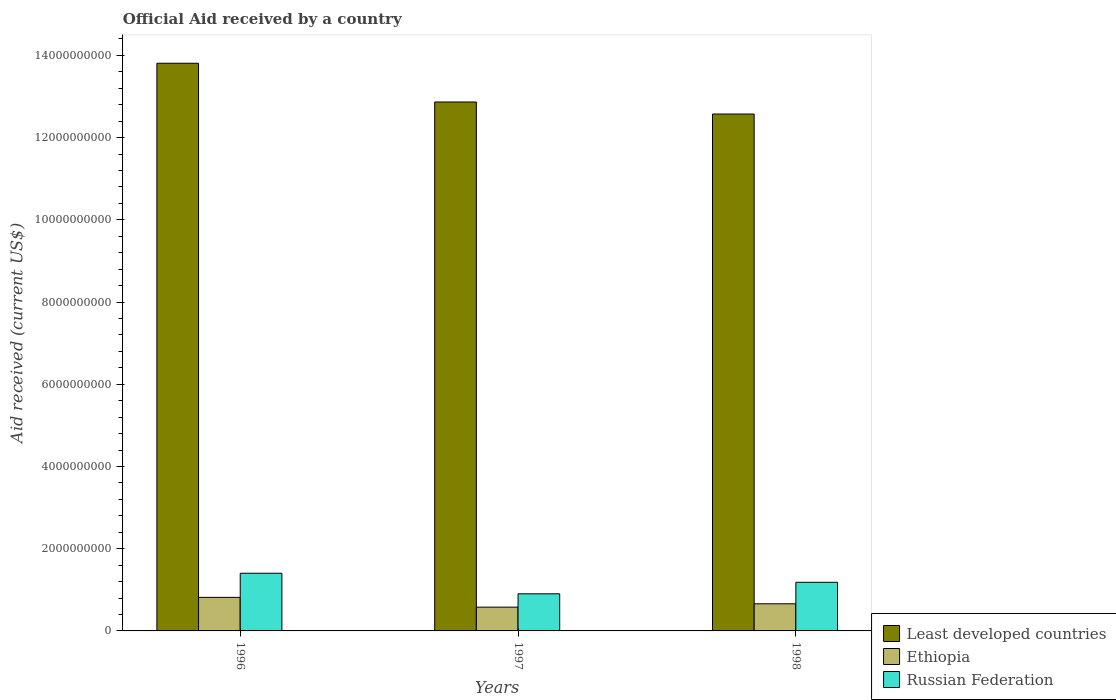How many different coloured bars are there?
Offer a terse response. 3. How many groups of bars are there?
Offer a terse response. 3. Are the number of bars per tick equal to the number of legend labels?
Offer a terse response. Yes. What is the label of the 1st group of bars from the left?
Your response must be concise. 1996. In how many cases, is the number of bars for a given year not equal to the number of legend labels?
Your answer should be compact. 0. What is the net official aid received in Ethiopia in 1997?
Your answer should be compact. 5.78e+08. Across all years, what is the maximum net official aid received in Ethiopia?
Give a very brief answer. 8.16e+08. Across all years, what is the minimum net official aid received in Ethiopia?
Provide a succinct answer. 5.78e+08. In which year was the net official aid received in Russian Federation maximum?
Ensure brevity in your answer.  1996. In which year was the net official aid received in Russian Federation minimum?
Provide a short and direct response. 1997. What is the total net official aid received in Ethiopia in the graph?
Ensure brevity in your answer.  2.05e+09. What is the difference between the net official aid received in Russian Federation in 1996 and that in 1997?
Your answer should be compact. 5.00e+08. What is the difference between the net official aid received in Ethiopia in 1998 and the net official aid received in Russian Federation in 1996?
Make the answer very short. -7.43e+08. What is the average net official aid received in Ethiopia per year?
Ensure brevity in your answer.  6.85e+08. In the year 1996, what is the difference between the net official aid received in Russian Federation and net official aid received in Ethiopia?
Offer a very short reply. 5.87e+08. What is the ratio of the net official aid received in Ethiopia in 1996 to that in 1998?
Ensure brevity in your answer.  1.24. Is the net official aid received in Russian Federation in 1997 less than that in 1998?
Provide a succinct answer. Yes. What is the difference between the highest and the second highest net official aid received in Least developed countries?
Keep it short and to the point. 9.42e+08. What is the difference between the highest and the lowest net official aid received in Ethiopia?
Make the answer very short. 2.38e+08. In how many years, is the net official aid received in Russian Federation greater than the average net official aid received in Russian Federation taken over all years?
Give a very brief answer. 2. Is the sum of the net official aid received in Least developed countries in 1997 and 1998 greater than the maximum net official aid received in Russian Federation across all years?
Make the answer very short. Yes. What does the 1st bar from the left in 1997 represents?
Offer a terse response. Least developed countries. What does the 3rd bar from the right in 1996 represents?
Keep it short and to the point. Least developed countries. Is it the case that in every year, the sum of the net official aid received in Least developed countries and net official aid received in Ethiopia is greater than the net official aid received in Russian Federation?
Keep it short and to the point. Yes. Are all the bars in the graph horizontal?
Provide a succinct answer. No. How many years are there in the graph?
Provide a succinct answer. 3. Where does the legend appear in the graph?
Make the answer very short. Bottom right. How many legend labels are there?
Keep it short and to the point. 3. How are the legend labels stacked?
Offer a very short reply. Vertical. What is the title of the graph?
Ensure brevity in your answer.  Official Aid received by a country. Does "Tajikistan" appear as one of the legend labels in the graph?
Keep it short and to the point. No. What is the label or title of the X-axis?
Give a very brief answer. Years. What is the label or title of the Y-axis?
Your answer should be very brief. Aid received (current US$). What is the Aid received (current US$) of Least developed countries in 1996?
Provide a short and direct response. 1.38e+1. What is the Aid received (current US$) in Ethiopia in 1996?
Keep it short and to the point. 8.16e+08. What is the Aid received (current US$) of Russian Federation in 1996?
Your answer should be compact. 1.40e+09. What is the Aid received (current US$) of Least developed countries in 1997?
Your response must be concise. 1.29e+1. What is the Aid received (current US$) in Ethiopia in 1997?
Ensure brevity in your answer.  5.78e+08. What is the Aid received (current US$) in Russian Federation in 1997?
Keep it short and to the point. 9.03e+08. What is the Aid received (current US$) of Least developed countries in 1998?
Keep it short and to the point. 1.26e+1. What is the Aid received (current US$) in Ethiopia in 1998?
Give a very brief answer. 6.60e+08. What is the Aid received (current US$) of Russian Federation in 1998?
Provide a succinct answer. 1.18e+09. Across all years, what is the maximum Aid received (current US$) of Least developed countries?
Keep it short and to the point. 1.38e+1. Across all years, what is the maximum Aid received (current US$) in Ethiopia?
Make the answer very short. 8.16e+08. Across all years, what is the maximum Aid received (current US$) in Russian Federation?
Your answer should be very brief. 1.40e+09. Across all years, what is the minimum Aid received (current US$) in Least developed countries?
Provide a succinct answer. 1.26e+1. Across all years, what is the minimum Aid received (current US$) in Ethiopia?
Ensure brevity in your answer.  5.78e+08. Across all years, what is the minimum Aid received (current US$) of Russian Federation?
Your response must be concise. 9.03e+08. What is the total Aid received (current US$) of Least developed countries in the graph?
Give a very brief answer. 3.92e+1. What is the total Aid received (current US$) in Ethiopia in the graph?
Your answer should be very brief. 2.05e+09. What is the total Aid received (current US$) of Russian Federation in the graph?
Keep it short and to the point. 3.49e+09. What is the difference between the Aid received (current US$) in Least developed countries in 1996 and that in 1997?
Your response must be concise. 9.42e+08. What is the difference between the Aid received (current US$) in Ethiopia in 1996 and that in 1997?
Provide a short and direct response. 2.38e+08. What is the difference between the Aid received (current US$) of Russian Federation in 1996 and that in 1997?
Your answer should be compact. 5.00e+08. What is the difference between the Aid received (current US$) in Least developed countries in 1996 and that in 1998?
Make the answer very short. 1.24e+09. What is the difference between the Aid received (current US$) of Ethiopia in 1996 and that in 1998?
Your answer should be compact. 1.56e+08. What is the difference between the Aid received (current US$) of Russian Federation in 1996 and that in 1998?
Provide a succinct answer. 2.20e+08. What is the difference between the Aid received (current US$) in Least developed countries in 1997 and that in 1998?
Provide a short and direct response. 2.93e+08. What is the difference between the Aid received (current US$) of Ethiopia in 1997 and that in 1998?
Ensure brevity in your answer.  -8.18e+07. What is the difference between the Aid received (current US$) in Russian Federation in 1997 and that in 1998?
Your answer should be very brief. -2.80e+08. What is the difference between the Aid received (current US$) in Least developed countries in 1996 and the Aid received (current US$) in Ethiopia in 1997?
Ensure brevity in your answer.  1.32e+1. What is the difference between the Aid received (current US$) of Least developed countries in 1996 and the Aid received (current US$) of Russian Federation in 1997?
Ensure brevity in your answer.  1.29e+1. What is the difference between the Aid received (current US$) of Ethiopia in 1996 and the Aid received (current US$) of Russian Federation in 1997?
Make the answer very short. -8.70e+07. What is the difference between the Aid received (current US$) in Least developed countries in 1996 and the Aid received (current US$) in Ethiopia in 1998?
Offer a very short reply. 1.31e+1. What is the difference between the Aid received (current US$) in Least developed countries in 1996 and the Aid received (current US$) in Russian Federation in 1998?
Give a very brief answer. 1.26e+1. What is the difference between the Aid received (current US$) in Ethiopia in 1996 and the Aid received (current US$) in Russian Federation in 1998?
Give a very brief answer. -3.67e+08. What is the difference between the Aid received (current US$) in Least developed countries in 1997 and the Aid received (current US$) in Ethiopia in 1998?
Your answer should be very brief. 1.22e+1. What is the difference between the Aid received (current US$) of Least developed countries in 1997 and the Aid received (current US$) of Russian Federation in 1998?
Offer a very short reply. 1.17e+1. What is the difference between the Aid received (current US$) in Ethiopia in 1997 and the Aid received (current US$) in Russian Federation in 1998?
Your answer should be very brief. -6.05e+08. What is the average Aid received (current US$) of Least developed countries per year?
Give a very brief answer. 1.31e+1. What is the average Aid received (current US$) of Ethiopia per year?
Keep it short and to the point. 6.85e+08. What is the average Aid received (current US$) of Russian Federation per year?
Offer a terse response. 1.16e+09. In the year 1996, what is the difference between the Aid received (current US$) in Least developed countries and Aid received (current US$) in Ethiopia?
Keep it short and to the point. 1.30e+1. In the year 1996, what is the difference between the Aid received (current US$) of Least developed countries and Aid received (current US$) of Russian Federation?
Offer a very short reply. 1.24e+1. In the year 1996, what is the difference between the Aid received (current US$) of Ethiopia and Aid received (current US$) of Russian Federation?
Your answer should be very brief. -5.87e+08. In the year 1997, what is the difference between the Aid received (current US$) of Least developed countries and Aid received (current US$) of Ethiopia?
Your answer should be very brief. 1.23e+1. In the year 1997, what is the difference between the Aid received (current US$) in Least developed countries and Aid received (current US$) in Russian Federation?
Your answer should be compact. 1.20e+1. In the year 1997, what is the difference between the Aid received (current US$) in Ethiopia and Aid received (current US$) in Russian Federation?
Offer a terse response. -3.25e+08. In the year 1998, what is the difference between the Aid received (current US$) in Least developed countries and Aid received (current US$) in Ethiopia?
Give a very brief answer. 1.19e+1. In the year 1998, what is the difference between the Aid received (current US$) in Least developed countries and Aid received (current US$) in Russian Federation?
Give a very brief answer. 1.14e+1. In the year 1998, what is the difference between the Aid received (current US$) of Ethiopia and Aid received (current US$) of Russian Federation?
Offer a very short reply. -5.23e+08. What is the ratio of the Aid received (current US$) of Least developed countries in 1996 to that in 1997?
Give a very brief answer. 1.07. What is the ratio of the Aid received (current US$) of Ethiopia in 1996 to that in 1997?
Make the answer very short. 1.41. What is the ratio of the Aid received (current US$) of Russian Federation in 1996 to that in 1997?
Keep it short and to the point. 1.55. What is the ratio of the Aid received (current US$) in Least developed countries in 1996 to that in 1998?
Give a very brief answer. 1.1. What is the ratio of the Aid received (current US$) of Ethiopia in 1996 to that in 1998?
Provide a short and direct response. 1.24. What is the ratio of the Aid received (current US$) of Russian Federation in 1996 to that in 1998?
Offer a terse response. 1.19. What is the ratio of the Aid received (current US$) of Least developed countries in 1997 to that in 1998?
Provide a short and direct response. 1.02. What is the ratio of the Aid received (current US$) of Ethiopia in 1997 to that in 1998?
Provide a succinct answer. 0.88. What is the ratio of the Aid received (current US$) of Russian Federation in 1997 to that in 1998?
Your answer should be very brief. 0.76. What is the difference between the highest and the second highest Aid received (current US$) of Least developed countries?
Offer a terse response. 9.42e+08. What is the difference between the highest and the second highest Aid received (current US$) of Ethiopia?
Provide a short and direct response. 1.56e+08. What is the difference between the highest and the second highest Aid received (current US$) in Russian Federation?
Provide a short and direct response. 2.20e+08. What is the difference between the highest and the lowest Aid received (current US$) in Least developed countries?
Offer a terse response. 1.24e+09. What is the difference between the highest and the lowest Aid received (current US$) in Ethiopia?
Offer a terse response. 2.38e+08. What is the difference between the highest and the lowest Aid received (current US$) of Russian Federation?
Offer a very short reply. 5.00e+08. 